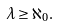Convert formula to latex. <formula><loc_0><loc_0><loc_500><loc_500>\lambda \geq \aleph _ { 0 } .</formula> 